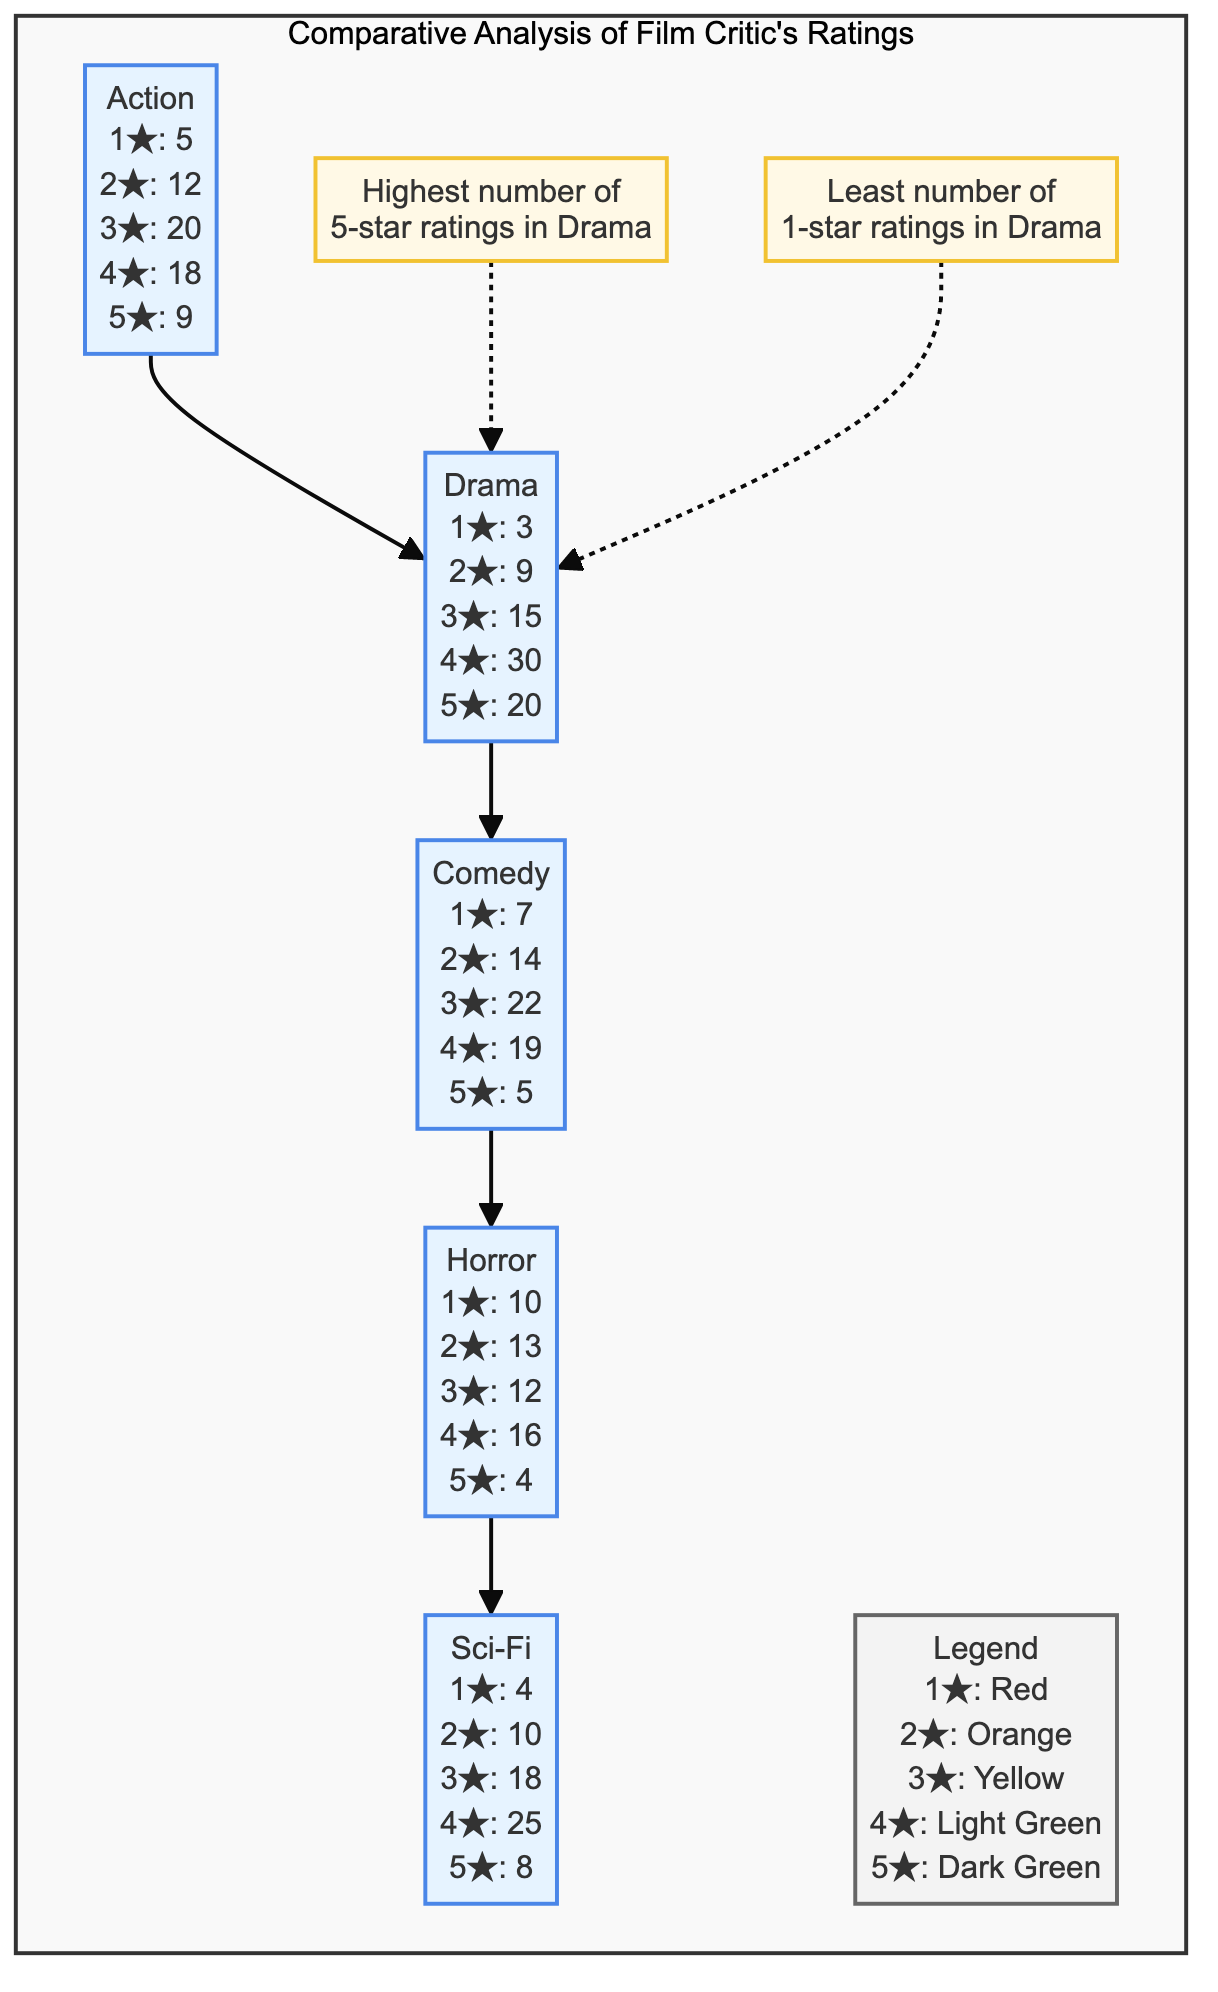What is the highest number of 5-star ratings and which genre has it? The diagram indicates the number of 5-star ratings for the different genres. Upon reviewing the numbers, Drama has 20 5-star ratings, which is higher than any other genre.
Answer: Drama How many 1-star ratings did the Comedy genre receive? The diagram specifies the number of 1-star ratings for Comedy as 7. This is directly listed in the Comedy node of the diagram for reference.
Answer: 7 Which genre has the least number of 1-star ratings? By comparing the number of 1-star ratings across genres, Drama has the least with only 3. This information can be seen directly in the Drama node.
Answer: Drama What is the total number of 4-star ratings across all genres? To calculate the total, we add the 4-star ratings from each genre: Action (18) + Drama (30) + Comedy (19) + Horror (16) + Sci-Fi (25) = 108. This requires summation of the 4-star ratings from all genre nodes.
Answer: 108 Which genre received the most 1-star ratings and how many were there? Examining the 1-star ratings, Horror has the highest count with 10. This is directly visible in the Horror node of the diagram.
Answer: Horror; 10 How many total genres are compared in this diagram? The diagram lists five genres: Action, Drama, Comedy, Horror, and Sci-Fi. Simply counting these entries gives us the answer directly.
Answer: 5 What color represents the 3-star ratings in the legend? The legend clearly indicates that 3-star ratings are color-coded yellow. This information is directly shown in the Legend node.
Answer: Yellow Which genre received the fewest 5-star ratings? By reviewing the number of 5-star ratings, Comedy has the fewest with only 5. This is described in the Comedy node specifically.
Answer: Comedy; 5 How many total ratings (1 to 5 stars) did Action receive? To find the total ratings for Action, we sum all the star ratings: 5 (1★) + 12 (2★) + 20 (3★) + 18 (4★) + 9 (5★) = 64. This is done by adding the values listed under Action in the diagram.
Answer: 64 